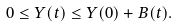<formula> <loc_0><loc_0><loc_500><loc_500>0 \leq Y ( t ) \leq Y ( 0 ) + B ( t ) .</formula> 